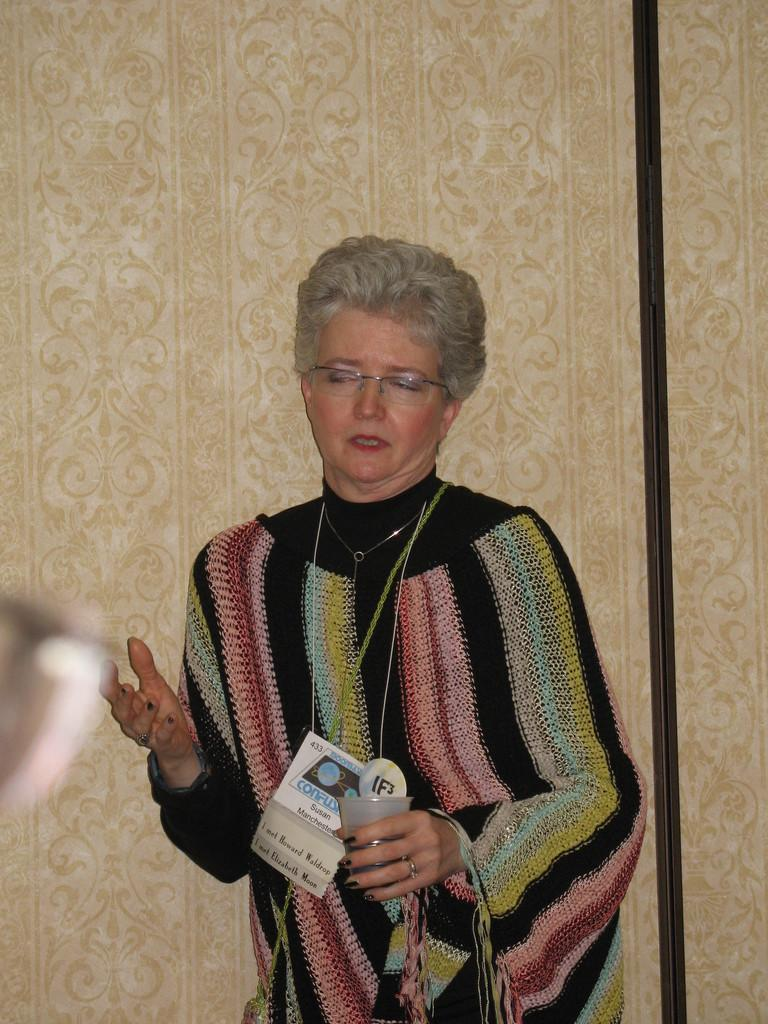Who is the main subject in the image? There is a woman in the image. What is the woman doing in the image? The woman is standing in the image. What is the woman holding in her hand? The woman is holding a glass and a wire tag in the image. What can be seen behind the woman in the image? There is a wall visible behind the woman in the image. What grade does the woman receive in the image? There is no indication of a grade or any educational context in the image. 